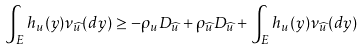Convert formula to latex. <formula><loc_0><loc_0><loc_500><loc_500>\int _ { E } h _ { u } ( y ) \nu _ { \widehat { u } } ( d y ) \geq - \rho _ { u } D _ { \widehat { u } } + \rho _ { \widehat { u } } D _ { \widehat { u } } + \int _ { E } h _ { u } ( y ) \nu _ { \widehat { u } } ( d y )</formula> 